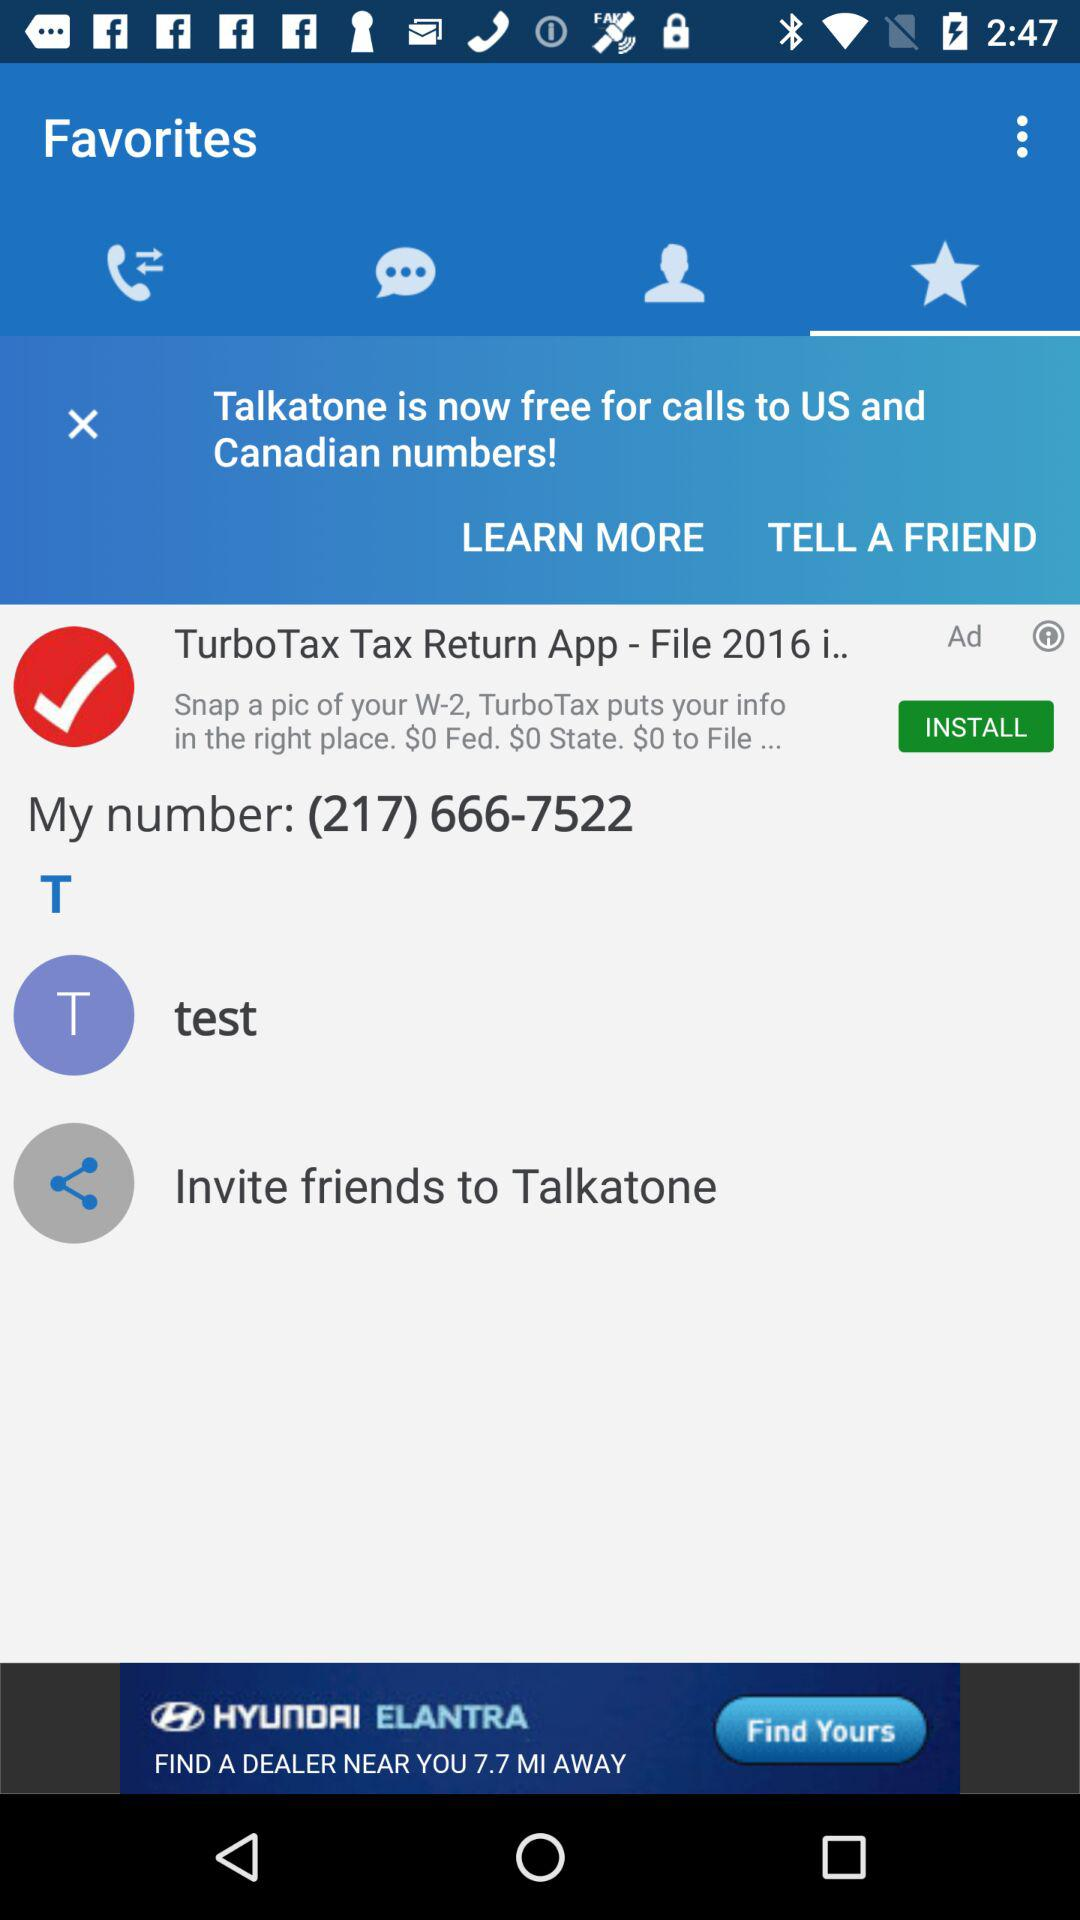Which tab am I on? You are on the "Favorites" tab. 